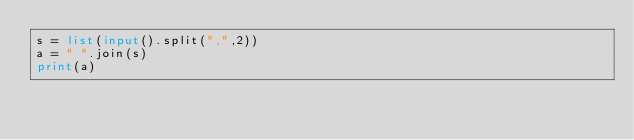Convert code to text. <code><loc_0><loc_0><loc_500><loc_500><_Python_>s = list(input().split(",",2))
a = " ".join(s)
print(a)
</code> 